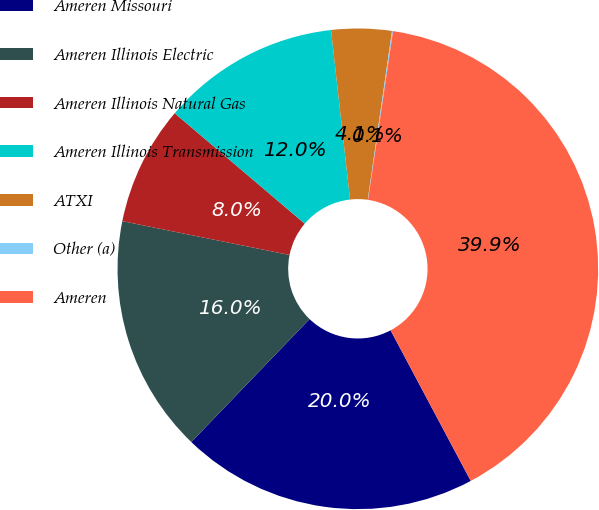Convert chart. <chart><loc_0><loc_0><loc_500><loc_500><pie_chart><fcel>Ameren Missouri<fcel>Ameren Illinois Electric<fcel>Ameren Illinois Natural Gas<fcel>Ameren Illinois Transmission<fcel>ATXI<fcel>Other (a)<fcel>Ameren<nl><fcel>19.97%<fcel>15.99%<fcel>8.03%<fcel>12.01%<fcel>4.05%<fcel>0.07%<fcel>39.87%<nl></chart> 